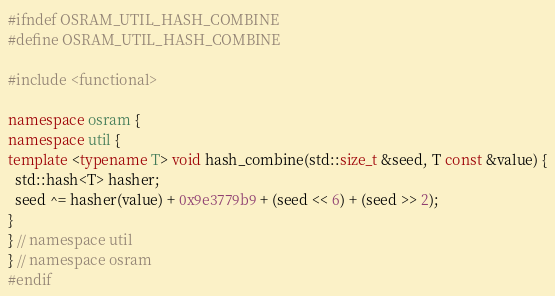Convert code to text. <code><loc_0><loc_0><loc_500><loc_500><_C++_>#ifndef OSRAM_UTIL_HASH_COMBINE
#define OSRAM_UTIL_HASH_COMBINE

#include <functional>

namespace osram {
namespace util {
template <typename T> void hash_combine(std::size_t &seed, T const &value) {
  std::hash<T> hasher;
  seed ^= hasher(value) + 0x9e3779b9 + (seed << 6) + (seed >> 2);
}
} // namespace util
} // namespace osram
#endif
</code> 